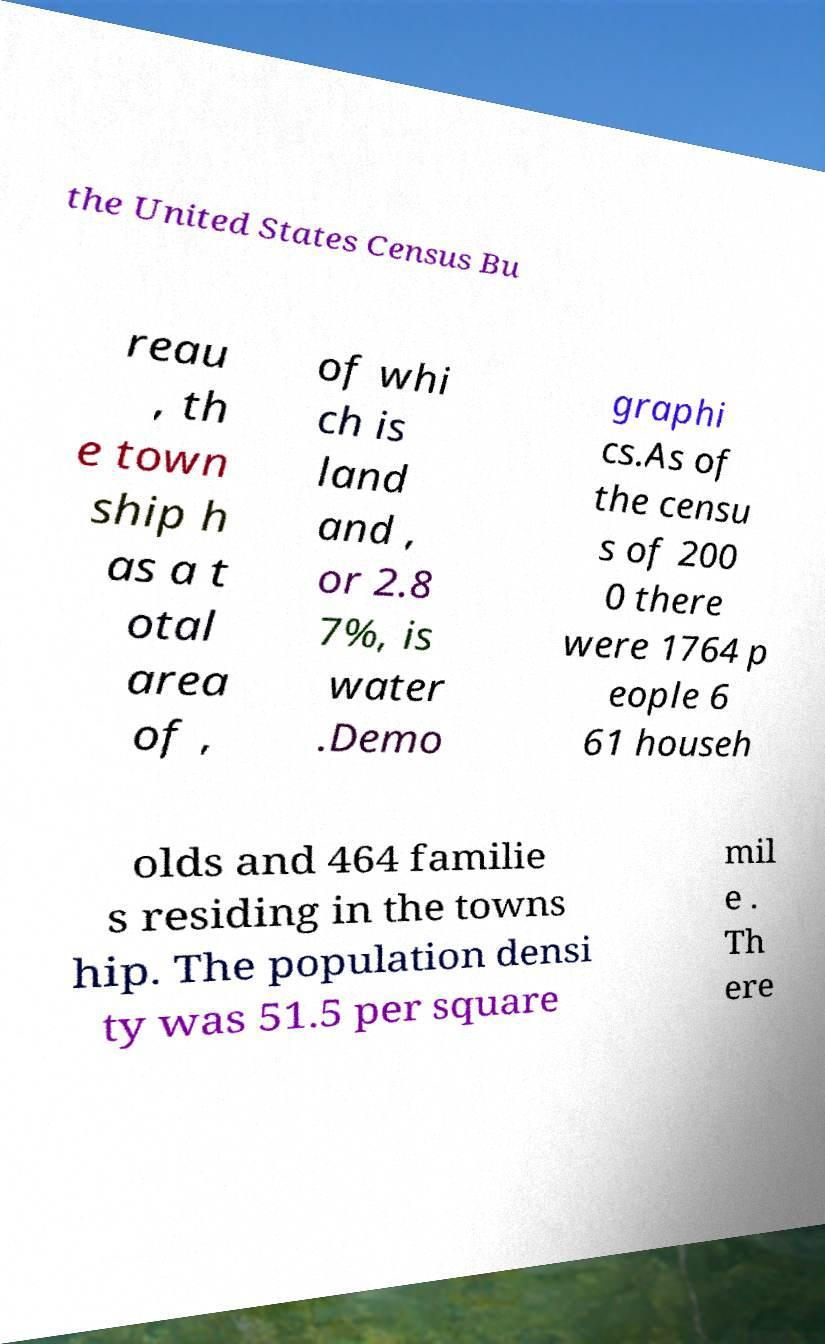What messages or text are displayed in this image? I need them in a readable, typed format. the United States Census Bu reau , th e town ship h as a t otal area of , of whi ch is land and , or 2.8 7%, is water .Demo graphi cs.As of the censu s of 200 0 there were 1764 p eople 6 61 househ olds and 464 familie s residing in the towns hip. The population densi ty was 51.5 per square mil e . Th ere 